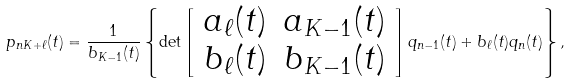Convert formula to latex. <formula><loc_0><loc_0><loc_500><loc_500>p _ { n K + \ell } ( t ) = \frac { 1 } { b _ { K - 1 } ( t ) } \left \{ \det \left [ \begin{array} { c c } a _ { \ell } ( t ) & a _ { K - 1 } ( t ) \\ b _ { \ell } ( t ) & b _ { K - 1 } ( t ) \end{array} \right ] q _ { n - 1 } ( t ) + b _ { \ell } ( t ) q _ { n } ( t ) \right \} ,</formula> 